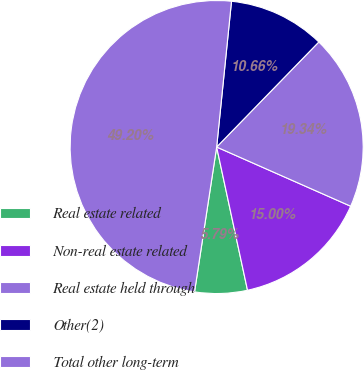Convert chart. <chart><loc_0><loc_0><loc_500><loc_500><pie_chart><fcel>Real estate related<fcel>Non-real estate related<fcel>Real estate held through<fcel>Other(2)<fcel>Total other long-term<nl><fcel>5.79%<fcel>15.0%<fcel>19.34%<fcel>10.66%<fcel>49.2%<nl></chart> 